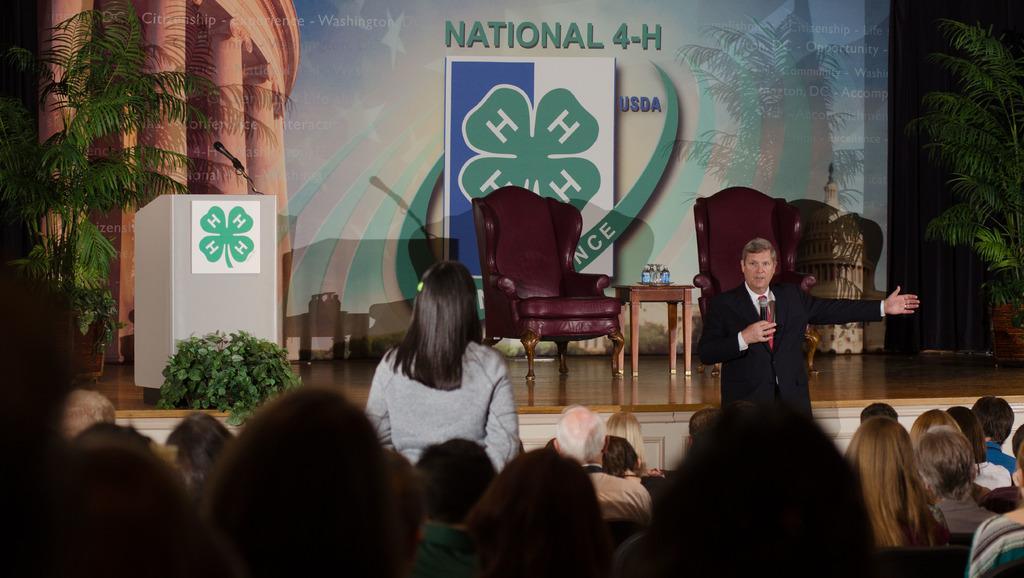Can you describe this image briefly? Here we can see a man standing with a microphone in his hand speaking something and in front of him there are group of people sitting and a woman Standing and on the stage we can see a couple of chairs and a table present and there are plants and a speech desk 